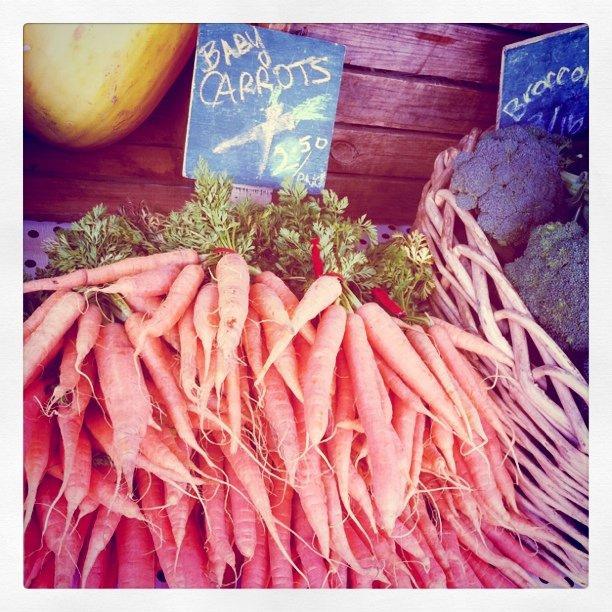Are those carrots organic?
Be succinct. No. Is this area in a market?
Give a very brief answer. Yes. What type of carrots are they?
Keep it brief. Baby. 